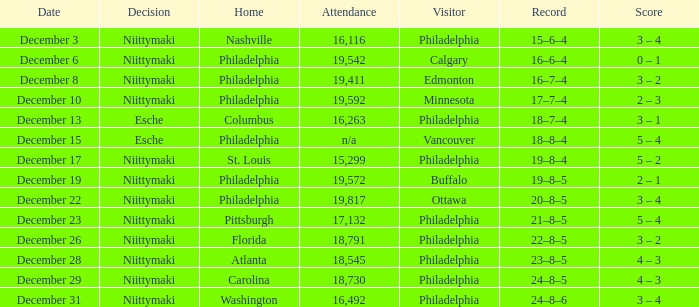What was the score when the attendance was 18,545? 4 – 3. 